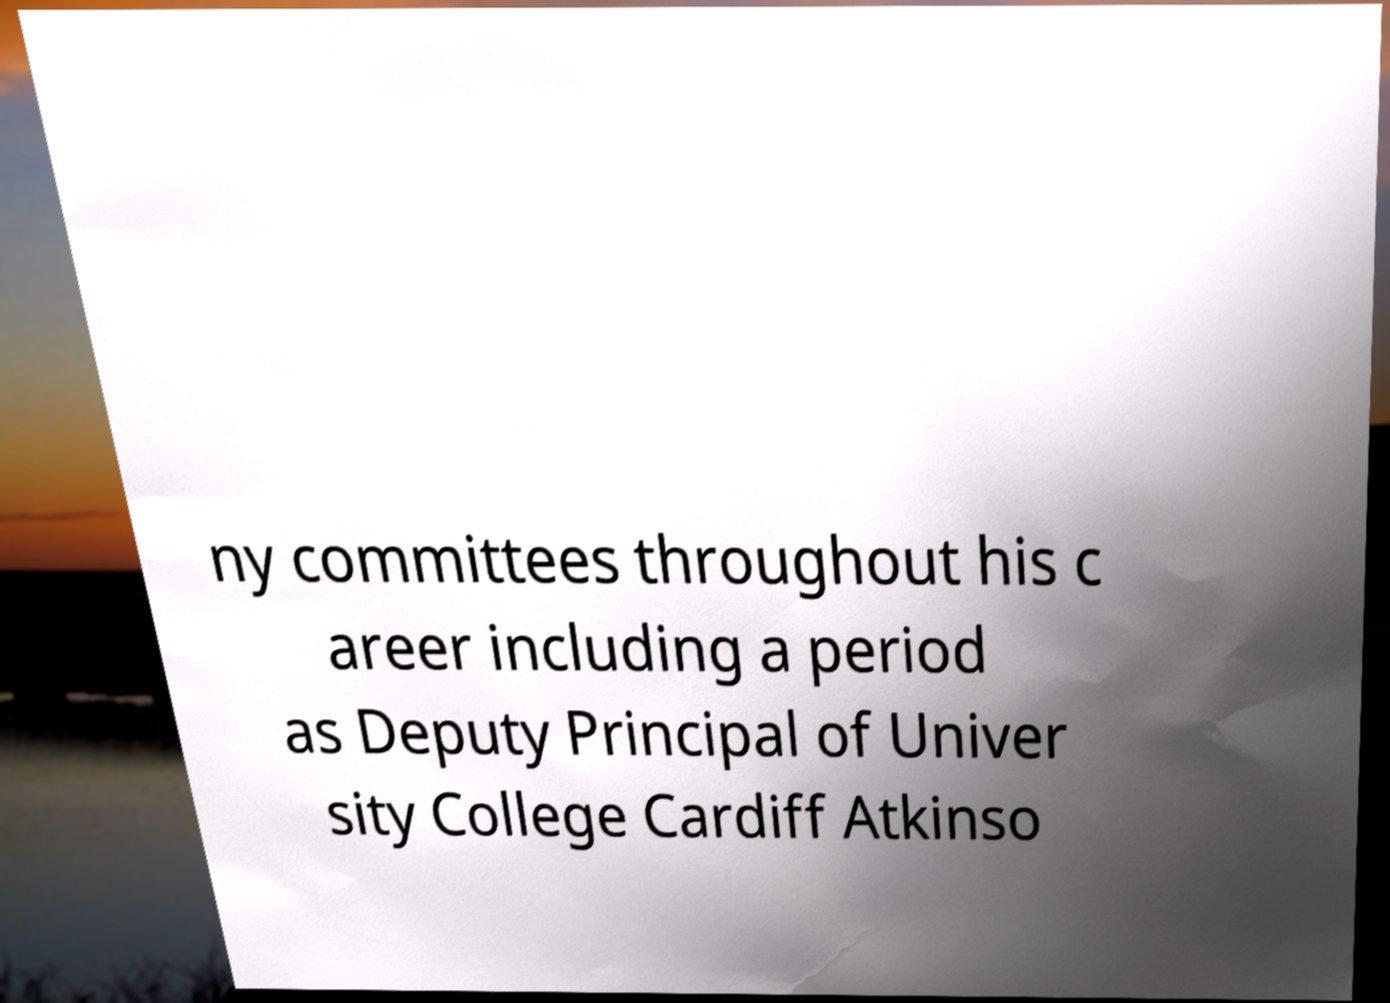Please read and relay the text visible in this image. What does it say? ny committees throughout his c areer including a period as Deputy Principal of Univer sity College Cardiff Atkinso 